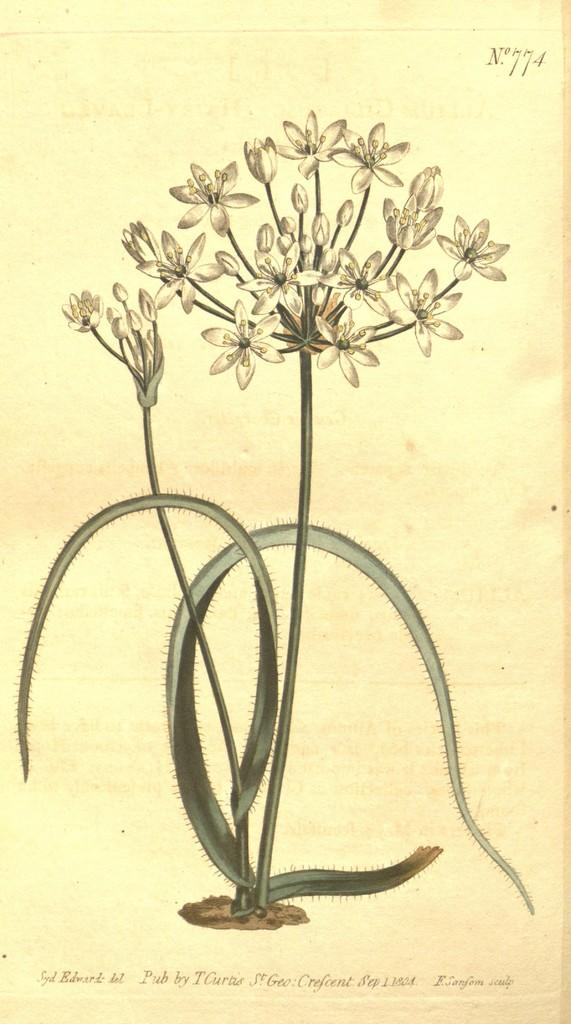What is the main subject of the paper in the image? The main subject of the paper in the image is a plant. Are there any other elements depicted on the paper? Yes, there are flowers depicted on the paper. What type of vegetable is depicted on the paper? There is no vegetable depicted on the paper; it features a plant and flowers. Is there any paste visible on the paper? There is no paste visible on the paper; it is a depiction of a plant and flowers. 